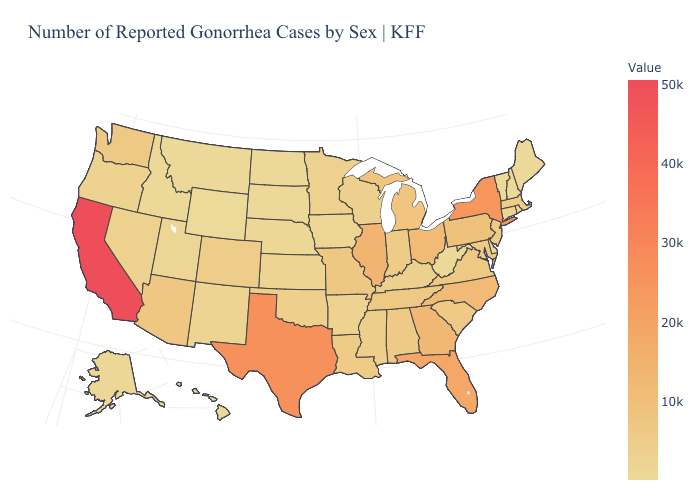Among the states that border Ohio , which have the highest value?
Answer briefly. Pennsylvania. Does the map have missing data?
Concise answer only. No. Which states have the highest value in the USA?
Quick response, please. California. Which states have the lowest value in the West?
Write a very short answer. Wyoming. Which states have the lowest value in the Northeast?
Be succinct. Vermont. 